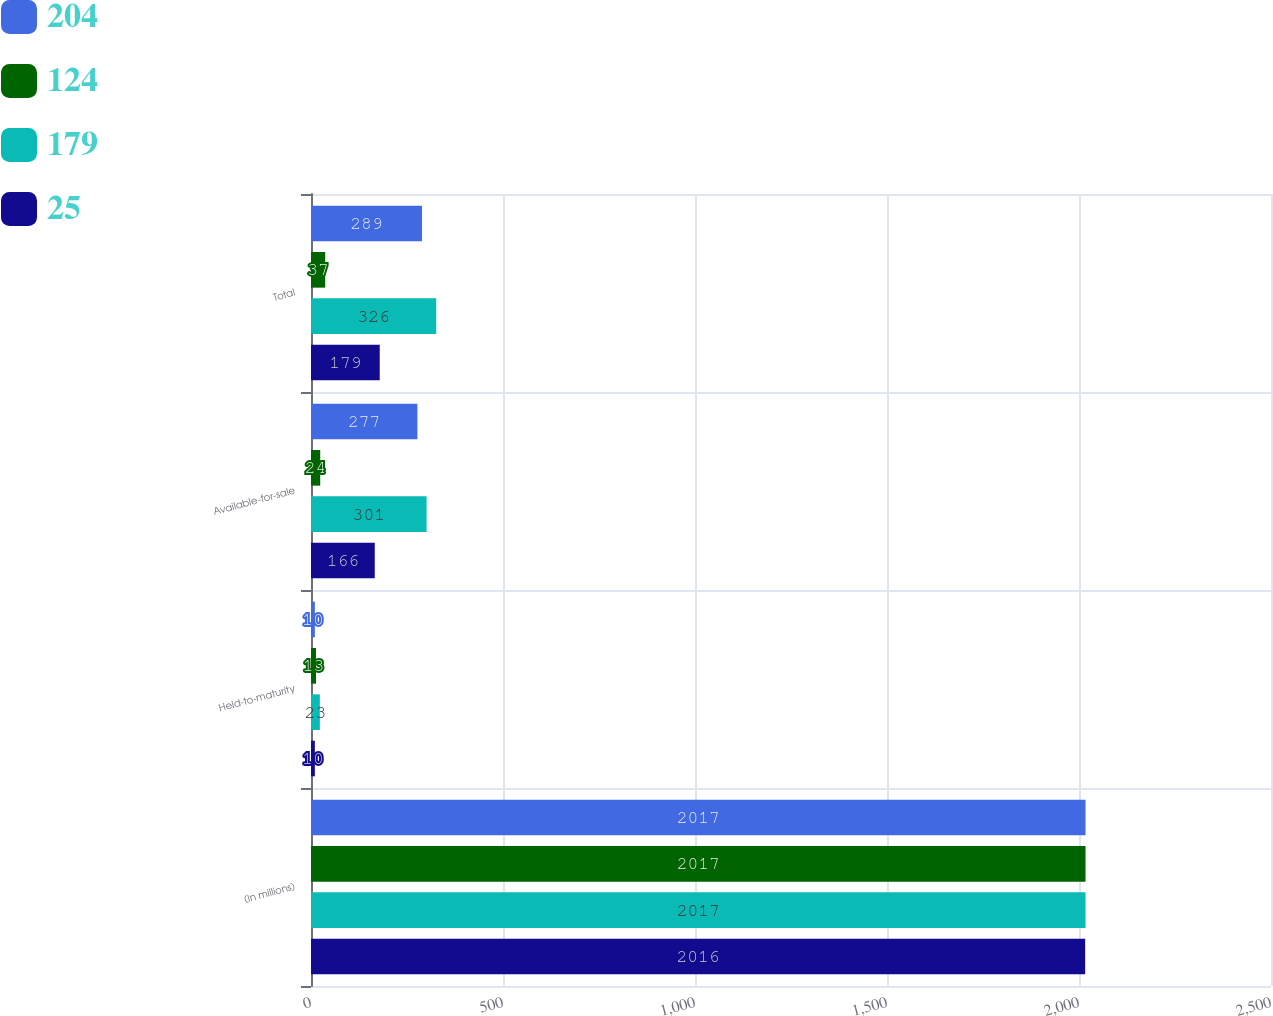Convert chart. <chart><loc_0><loc_0><loc_500><loc_500><stacked_bar_chart><ecel><fcel>(In millions)<fcel>Held-to-maturity<fcel>Available-for-sale<fcel>Total<nl><fcel>204<fcel>2017<fcel>10<fcel>277<fcel>289<nl><fcel>124<fcel>2017<fcel>13<fcel>24<fcel>37<nl><fcel>179<fcel>2017<fcel>23<fcel>301<fcel>326<nl><fcel>25<fcel>2016<fcel>10<fcel>166<fcel>179<nl></chart> 